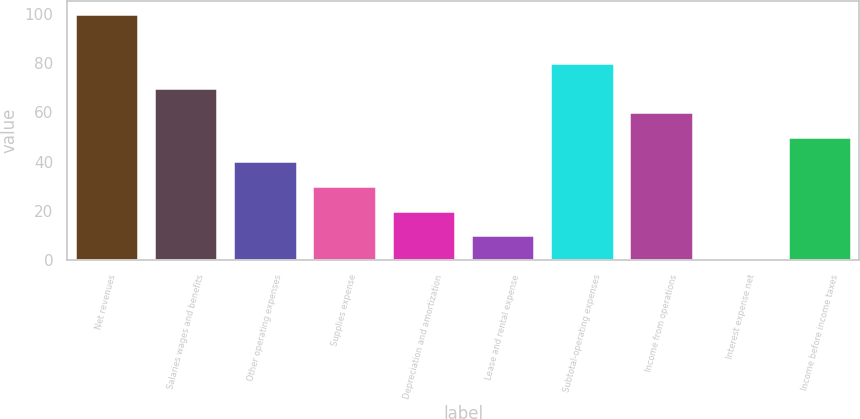<chart> <loc_0><loc_0><loc_500><loc_500><bar_chart><fcel>Net revenues<fcel>Salaries wages and benefits<fcel>Other operating expenses<fcel>Supplies expense<fcel>Depreciation and amortization<fcel>Lease and rental expense<fcel>Subtotal-operating expenses<fcel>Income from operations<fcel>Interest expense net<fcel>Income before income taxes<nl><fcel>100<fcel>70.03<fcel>40.06<fcel>30.07<fcel>20.08<fcel>10.09<fcel>80.02<fcel>60.04<fcel>0.1<fcel>50.05<nl></chart> 